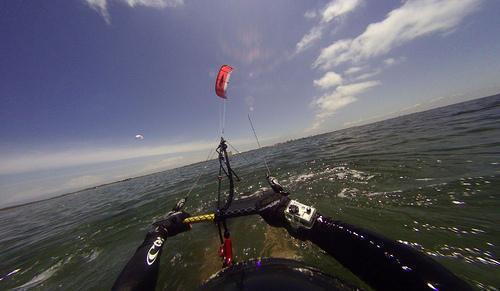How many parasails are in the air?
Give a very brief answer. 2. 